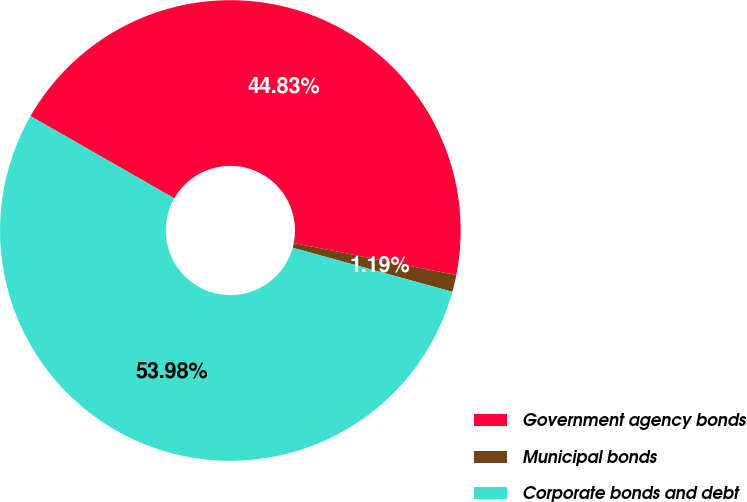Convert chart to OTSL. <chart><loc_0><loc_0><loc_500><loc_500><pie_chart><fcel>Government agency bonds<fcel>Municipal bonds<fcel>Corporate bonds and debt<nl><fcel>44.83%<fcel>1.19%<fcel>53.99%<nl></chart> 